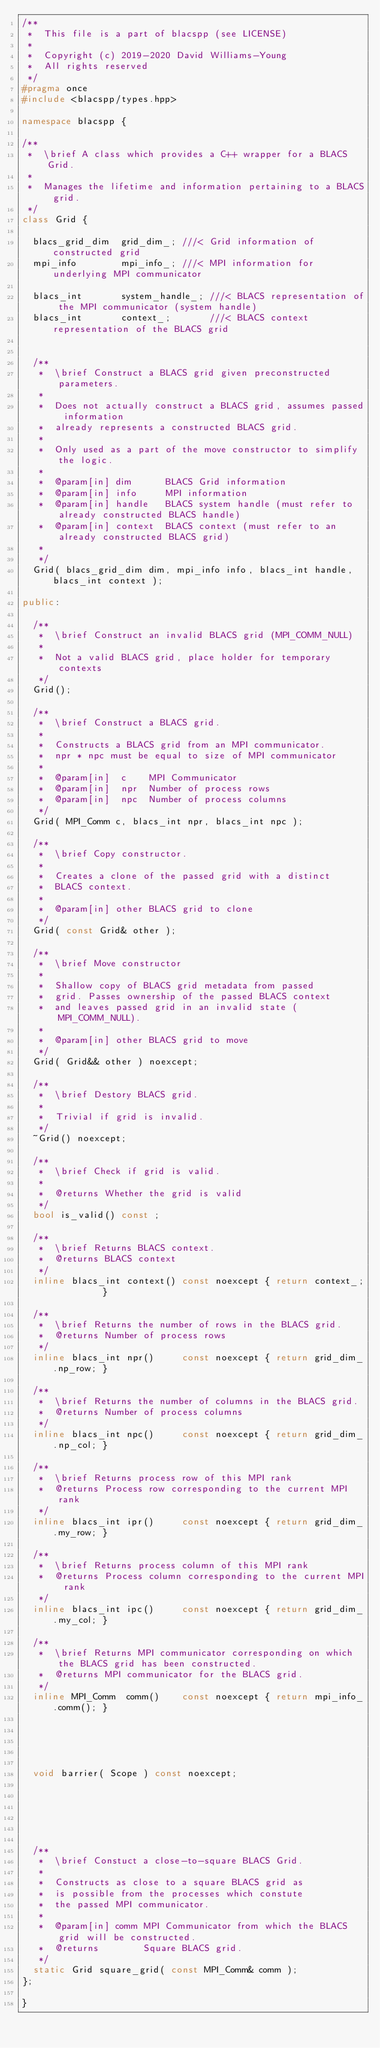Convert code to text. <code><loc_0><loc_0><loc_500><loc_500><_C++_>/**
 *  This file is a part of blacspp (see LICENSE)
 *
 *  Copyright (c) 2019-2020 David Williams-Young
 *  All rights reserved
 */
#pragma once
#include <blacspp/types.hpp>

namespace blacspp {

/**
 *  \brief A class which provides a C++ wrapper for a BLACS Grid.
 *
 *  Manages the lifetime and information pertaining to a BLACS grid.
 */
class Grid {

  blacs_grid_dim  grid_dim_; ///< Grid information of constructed grid
  mpi_info        mpi_info_; ///< MPI information for underlying MPI communicator

  blacs_int       system_handle_; ///< BLACS representation of the MPI communicator (system handle)
  blacs_int       context_;       ///< BLACS context representation of the BLACS grid
  

  /**
   *  \brief Construct a BLACS grid given preconstructed parameters.
   *
   *  Does not actually construct a BLACS grid, assumes passed information
   *  already represents a constructed BLACS grid.
   *
   *  Only used as a part of the move constructor to simplify the logic.
   *
   *  @param[in] dim      BLACS Grid information
   *  @param[in] info     MPI information
   *  @param[in] handle   BLACS system handle (must refer to already constructed BLACS handle)
   *  @param[in] context  BLACS context (must refer to an already constructed BLACS grid)
   *
   */
  Grid( blacs_grid_dim dim, mpi_info info, blacs_int handle, blacs_int context );

public:

  /**
   *  \brief Construct an invalid BLACS grid (MPI_COMM_NULL)
   *
   *  Not a valid BLACS grid, place holder for temporary contexts
   */
  Grid();

  /**
   *  \brief Construct a BLACS grid.
   *
   *  Constructs a BLACS grid from an MPI communicator.
   *  npr * npc must be equal to size of MPI communicator
   *
   *  @param[in]  c    MPI Communicator
   *  @param[in]  npr  Number of process rows
   *  @param[in]  npc  Number of process columns
   */
  Grid( MPI_Comm c, blacs_int npr, blacs_int npc );

  /**
   *  \brief Copy constructor.
   *
   *  Creates a clone of the passed grid with a distinct
   *  BLACS context.
   *
   *  @param[in] other BLACS grid to clone
   */
  Grid( const Grid& other );

  /**
   *  \brief Move constructor
   *
   *  Shallow copy of BLACS grid metadata from passed
   *  grid. Passes ownership of the passed BLACS context 
   *  and leaves passed grid in an invalid state (MPI_COMM_NULL).
   *
   *  @param[in] other BLACS grid to move
   */
  Grid( Grid&& other ) noexcept;  

  /**
   *  \brief Destory BLACS grid.
   *
   *  Trivial if grid is invalid.
   */
  ~Grid() noexcept;

  /**
   *  \brief Check if grid is valid.
   *
   *  @returns Whether the grid is valid
   */
  bool is_valid() const ;

  /**
   *  \brief Returns BLACS context.
   *  @returns BLACS context
   */
  inline blacs_int context() const noexcept { return context_;         }

  /**
   *  \brief Returns the number of rows in the BLACS grid.
   *  @returns Number of process rows
   */
  inline blacs_int npr()     const noexcept { return grid_dim_.np_row; }

  /**
   *  \brief Returns the number of columns in the BLACS grid.
   *  @returns Number of process columns
   */
  inline blacs_int npc()     const noexcept { return grid_dim_.np_col; }

  /**
   *  \brief Returns process row of this MPI rank
   *  @returns Process row corresponding to the current MPI rank
   */
  inline blacs_int ipr()     const noexcept { return grid_dim_.my_row; }

  /**
   *  \brief Returns process column of this MPI rank
   *  @returns Process column corresponding to the current MPI rank
   */
  inline blacs_int ipc()     const noexcept { return grid_dim_.my_col; }

  /**
   *  \brief Returns MPI communicator corresponding on which the BLACS grid has been constructed.
   *  @returns MPI communicator for the BLACS grid.
   */
  inline MPI_Comm  comm()    const noexcept { return mpi_info_.comm(); }





  void barrier( Scope ) const noexcept;






  /**
   *  \brief Constuct a close-to-square BLACS Grid.
   *
   *  Constructs as close to a square BLACS grid as
   *  is possible from the processes which constute
   *  the passed MPI communicator.
   *
   *  @param[in] comm MPI Communicator from which the BLACS grid will be constructed.
   *  @returns        Square BLACS grid.
   */
  static Grid square_grid( const MPI_Comm& comm );
};

}
</code> 